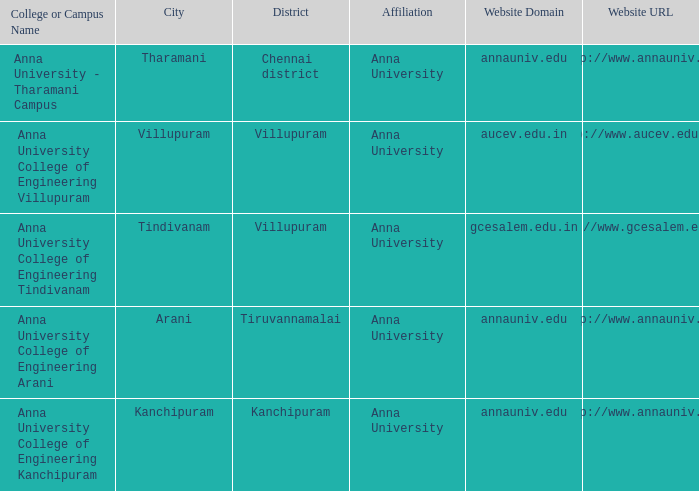What Location has a College or Campus Name of anna university - tharamani campus? Tharamani. 